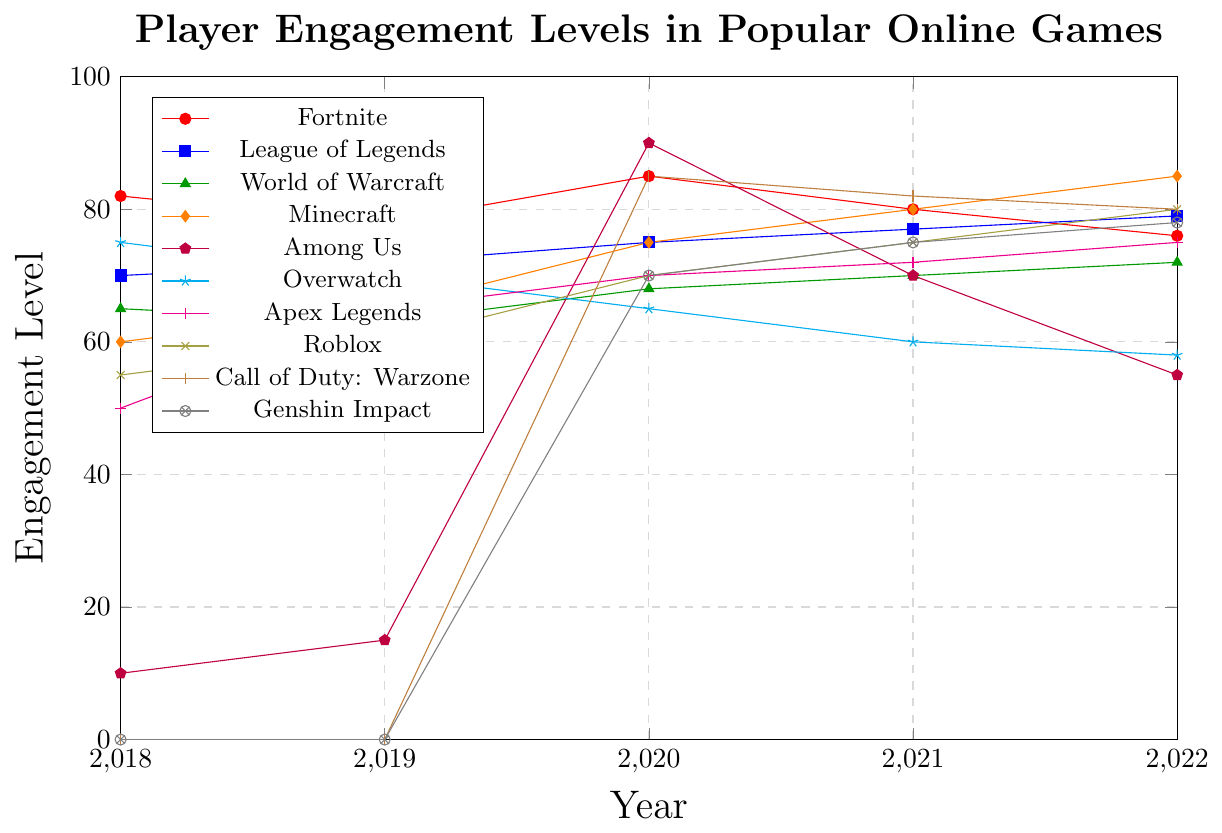What is the trend of player engagement levels for the game Fortnite from 2018 to 2022? From the figure, observe the plotted line for Fortnite. The engagement levels are 82 in 2018, 78 in 2019, 85 in 2020, 80 in 2021, and 76 in 2022. The engagement level increases from 2019 to 2020, then decreases steadily afterward.
Answer: A slight rise followed by a steady decline Which game had the highest engagement level in 2020? Look at the plotted lines for all games and identify the highest point for the year 2020. The highest engagement level in 2020 is 90 for Among Us.
Answer: Among Us How did the engagement level of World of Warcraft change from 2018 to 2022? Observe the line representing World of Warcraft. Engagement levels are 65 in 2018, 63 in 2019, 68 in 2020, 70 in 2021, and 72 in 2022. It first decreased, then increased steadily.
Answer: Decreased initially, then steadily increased Which game showed the most dramatic increase in engagement from 2019 to 2020? Compare all games' engagement levels between 2019 and 2020. Among Us shows a dramatic increase from 15 in 2019 to 90 in 2020.
Answer: Among Us What is the approximate average engagement level for Minecraft over the five years? Sum the yearly engagement levels of Minecraft (60 + 65 + 75 + 80 + 85) and divide by 5. The total is 365, and the average is 365/5.
Answer: 73 Which game had a consistently increasing trend from 2018 to 2022? Identify lines that show an upward trend each year. League of Legends, World of Warcraft, and Roblox show a consistent increase in engagement.
Answer: League of Legends, World of Warcraft, Roblox Between Fortnite and Overwatch, which game had higher player engagement in 2021? Compare the engagement levels for Fortnite (80) and Overwatch (60) in 2021. Fortnite had higher engagement.
Answer: Fortnite Did Apex Legends or Roblox start with a higher engagement level in 2018? Compare the engagement levels of Apex Legends (50) and Roblox (55) in 2018. Roblox had a higher engagement level.
Answer: Roblox What is the general trend observed for Among Us' player engagement from 2019 to 2022? Observe the plotted line for Among Us. The engagement level is 15 in 2019, peaks at 90 in 2020, decreases to 70 in 2021, and further reduces to 55 in 2022.
Answer: Increase, peak, then decline Which color line represents Genshin Impact, and what pattern does it show? Identify the color of the line assigned to Genshin Impact in the legend (gray). The pattern shows increasing engagement from 70 in 2020 to 78 in 2022.
Answer: Gray; increasing trend 